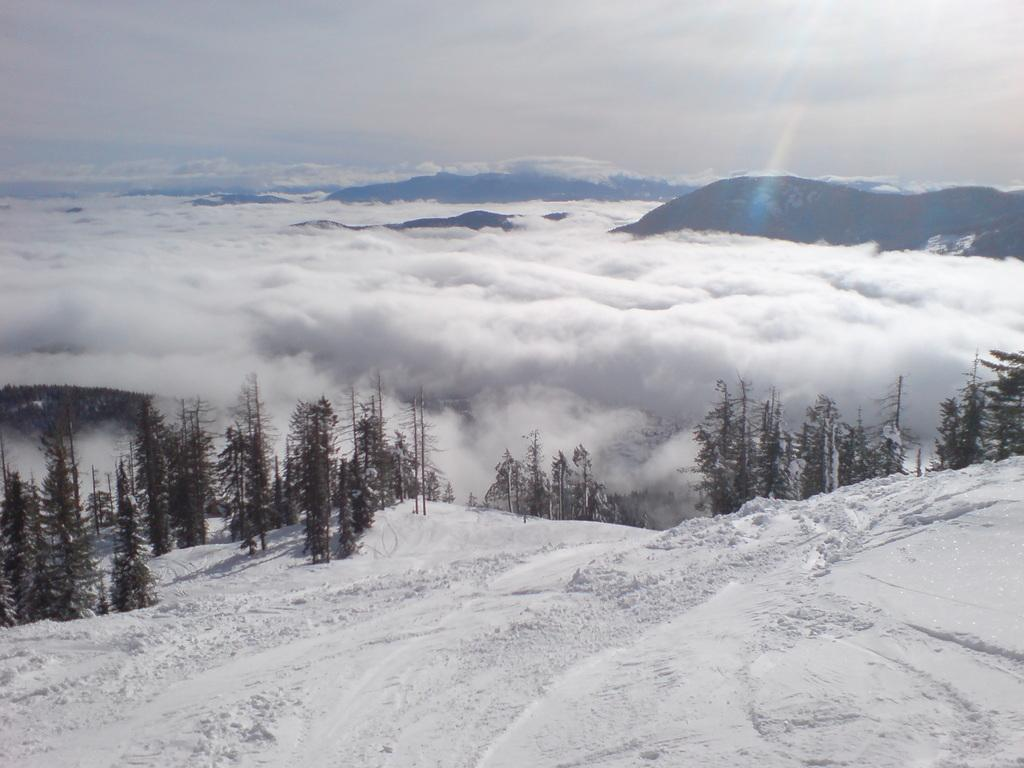What type of weather condition is depicted at the bottom of the image? There is snow at the bottom of the image, indicating a cold or wintery environment. What type of vegetation or natural elements can be seen in the image? There are trees in the image. What can be seen in the distance in the background of the image? There are mountains and clouds in the background of the image. Can you locate the elbow of the mountain in the image? There is no mention of an elbow in the image, as it features snow, trees, mountains, and clouds. 